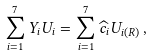Convert formula to latex. <formula><loc_0><loc_0><loc_500><loc_500>\sum _ { i = 1 } ^ { 7 } Y _ { i } U _ { i } = \sum _ { i = 1 } ^ { 7 } \widehat { c } _ { i } U _ { i ( R ) } \, ,</formula> 